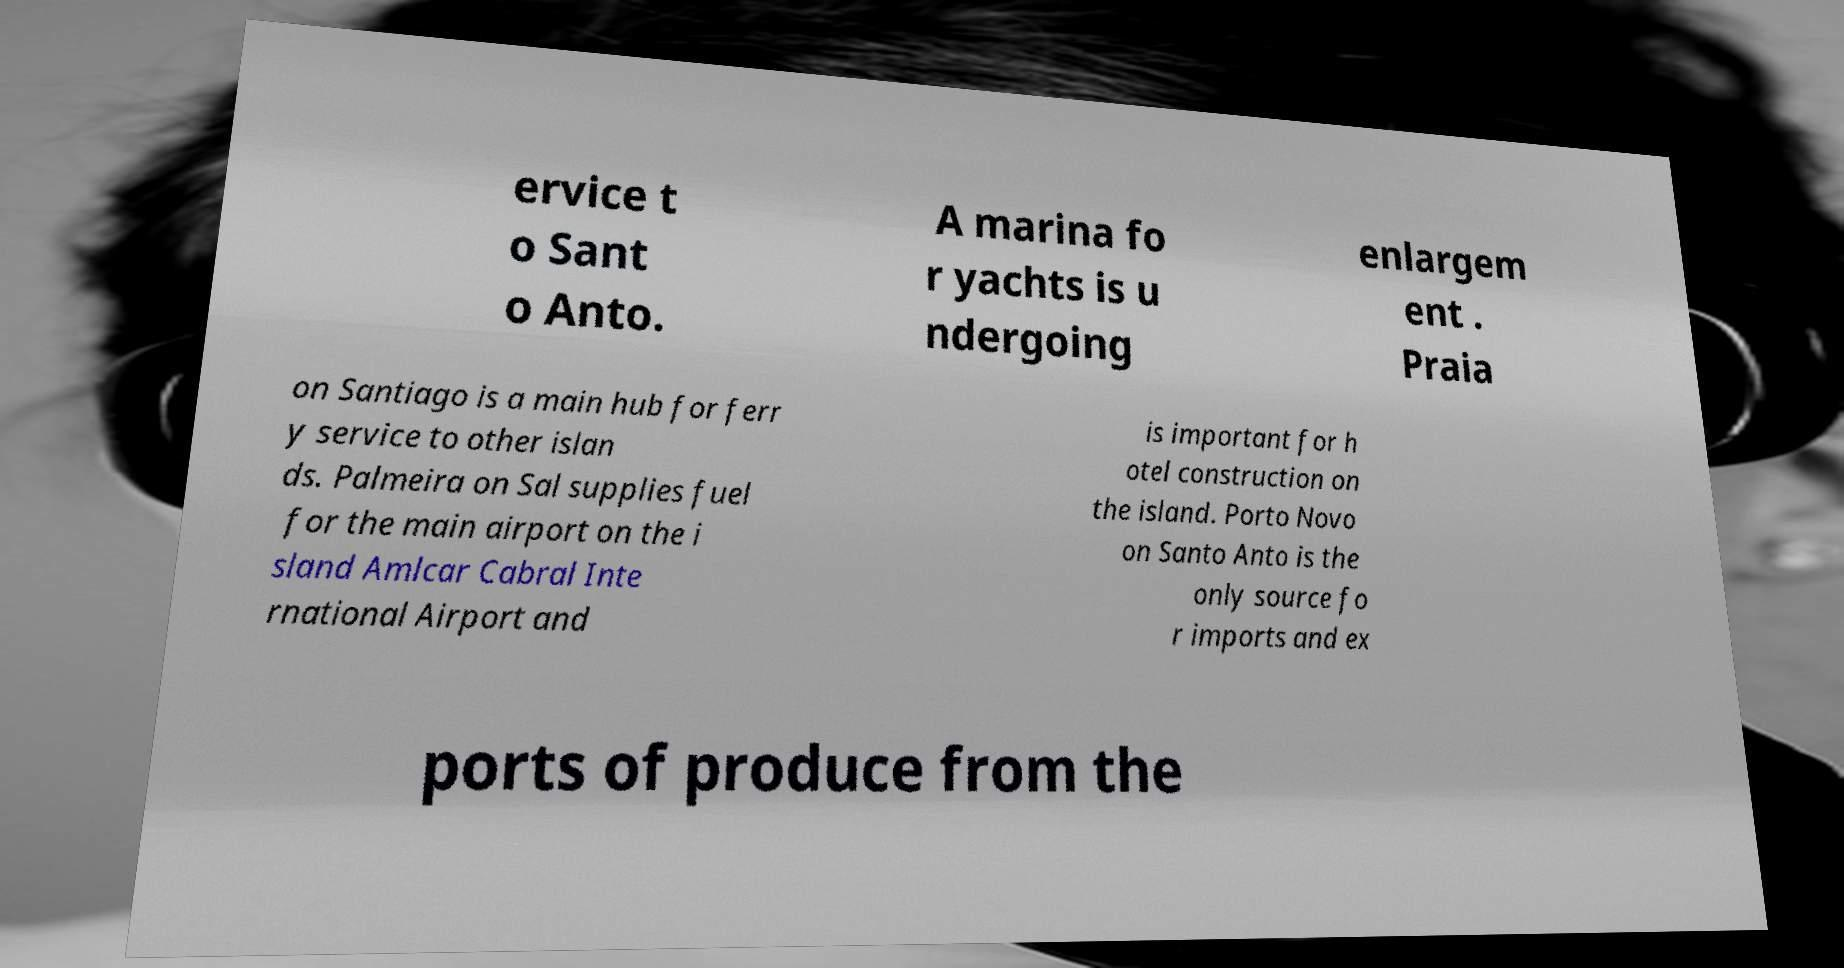What messages or text are displayed in this image? I need them in a readable, typed format. ervice t o Sant o Anto. A marina fo r yachts is u ndergoing enlargem ent . Praia on Santiago is a main hub for ferr y service to other islan ds. Palmeira on Sal supplies fuel for the main airport on the i sland Amlcar Cabral Inte rnational Airport and is important for h otel construction on the island. Porto Novo on Santo Anto is the only source fo r imports and ex ports of produce from the 